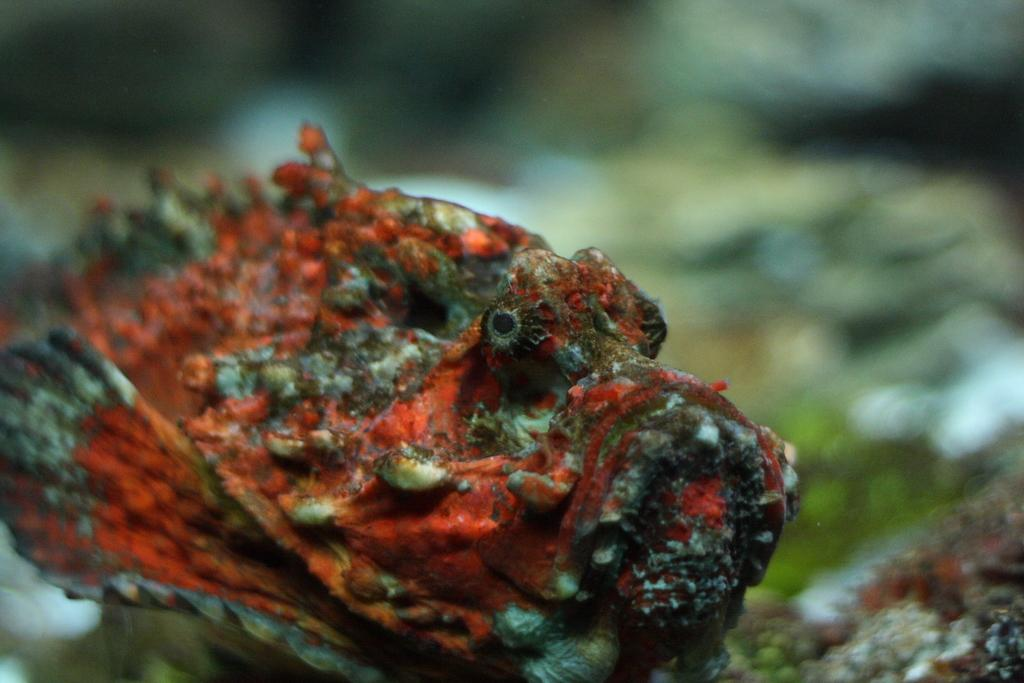What type of animals are in the image? There are fish in the image. What colors can be seen on the fish? The fish have orange and brown colors. Can you describe the background of the image? The background of the image is blurred. What type of nerve can be seen in the image? There is no nerve present in the image; it features fish with orange and brown colors against a blurred background. 